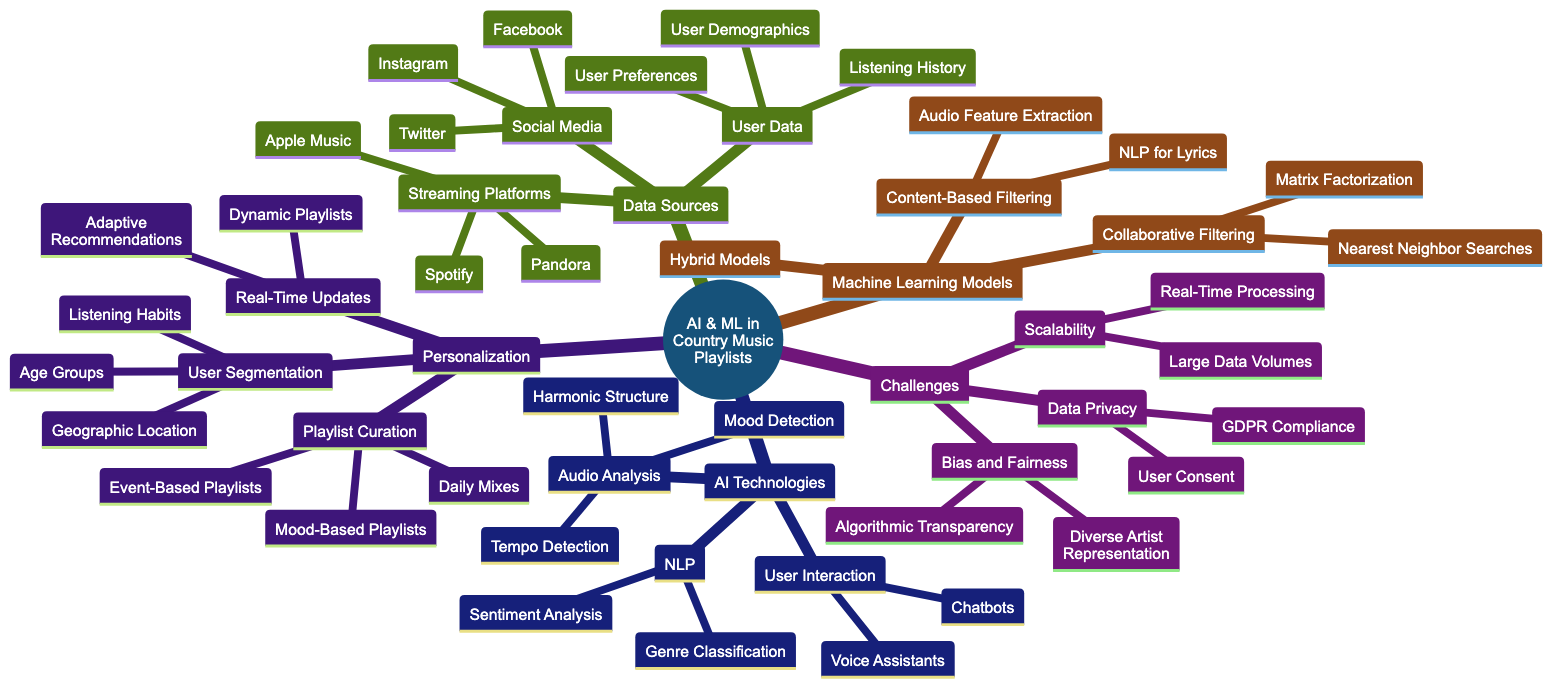What are the streaming platforms mentioned in the diagram? The diagram lists Spotify, Apple Music, and Pandora under the "Streaming Platforms" node of "Data Sources."
Answer: Spotify, Apple Music, Pandora How many AI technologies are listed in the diagram? There are three main AI technologies listed: Natural Language Processing, Audio Analysis, and User Interaction.
Answer: 3 What type of filtering is used in hybrid models? The hybrid models utilize a mix of collaborative and content-based filtering as indicated under "Machine Learning Models."
Answer: Mix of Collaborative and Content-Based What data privacy concern is mentioned in the diagram? The diagram indicates "GDPR Compliance" as a data privacy concern listed under "Challenges and Considerations."
Answer: GDPR Compliance Which user data aspects are considered for personalization? The diagram shows Listening History, User Preferences, and User Demographics under the "User Data" segment in "Data Sources."
Answer: Listening History, User Preferences, User Demographics How does sentiment analysis fit into AI technologies? Sentiment Analysis is a specific application of Natural Language Processing mentioned in the AI Technologies section of the diagram.
Answer: Natural Language Processing Which user segments are mentioned for personalization? The diagram lists Age Groups, Geographic Location, and Listening Habits under the "User Segmentation" section.
Answer: Age Groups, Geographic Location, Listening Habits What is the purpose of real-time updates in playlist curation? Real-time updates allow for Dynamic Playlists and Adaptive Recommendations, which are aimed at enhancing the user experience as depicted in the "Personalization" section.
Answer: Dynamic Playlists, Adaptive Recommendations What challenge relates to the scalability of AI-powered playlists? The diagram lists "Handling Large Data Volumes" as a challenge related to scalability in the "Challenges and Considerations" section.
Answer: Handling Large Data Volumes 